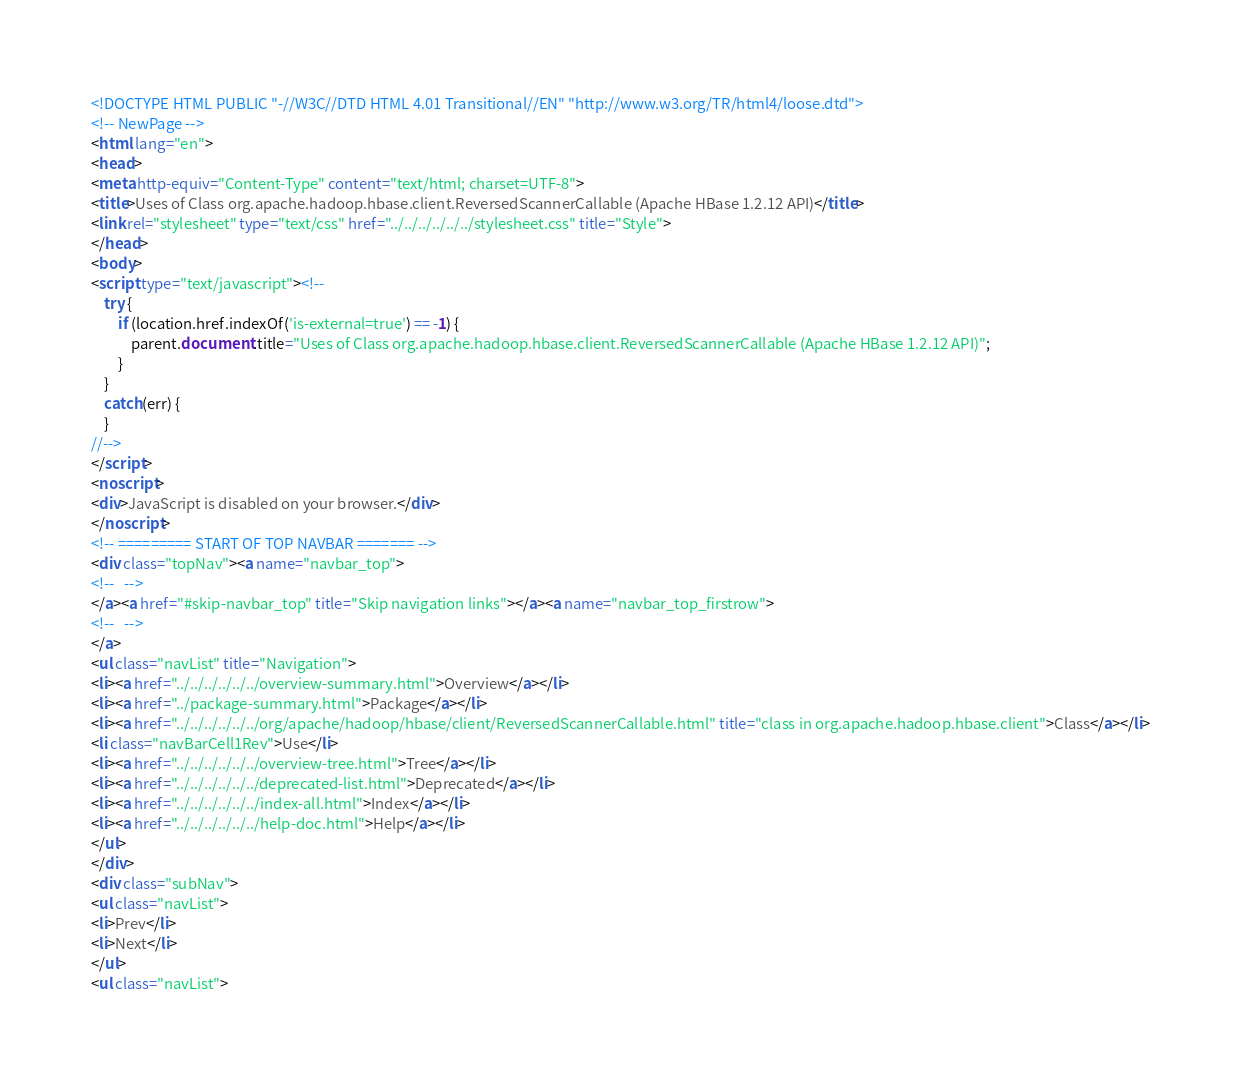<code> <loc_0><loc_0><loc_500><loc_500><_HTML_><!DOCTYPE HTML PUBLIC "-//W3C//DTD HTML 4.01 Transitional//EN" "http://www.w3.org/TR/html4/loose.dtd">
<!-- NewPage -->
<html lang="en">
<head>
<meta http-equiv="Content-Type" content="text/html; charset=UTF-8">
<title>Uses of Class org.apache.hadoop.hbase.client.ReversedScannerCallable (Apache HBase 1.2.12 API)</title>
<link rel="stylesheet" type="text/css" href="../../../../../../stylesheet.css" title="Style">
</head>
<body>
<script type="text/javascript"><!--
    try {
        if (location.href.indexOf('is-external=true') == -1) {
            parent.document.title="Uses of Class org.apache.hadoop.hbase.client.ReversedScannerCallable (Apache HBase 1.2.12 API)";
        }
    }
    catch(err) {
    }
//-->
</script>
<noscript>
<div>JavaScript is disabled on your browser.</div>
</noscript>
<!-- ========= START OF TOP NAVBAR ======= -->
<div class="topNav"><a name="navbar_top">
<!--   -->
</a><a href="#skip-navbar_top" title="Skip navigation links"></a><a name="navbar_top_firstrow">
<!--   -->
</a>
<ul class="navList" title="Navigation">
<li><a href="../../../../../../overview-summary.html">Overview</a></li>
<li><a href="../package-summary.html">Package</a></li>
<li><a href="../../../../../../org/apache/hadoop/hbase/client/ReversedScannerCallable.html" title="class in org.apache.hadoop.hbase.client">Class</a></li>
<li class="navBarCell1Rev">Use</li>
<li><a href="../../../../../../overview-tree.html">Tree</a></li>
<li><a href="../../../../../../deprecated-list.html">Deprecated</a></li>
<li><a href="../../../../../../index-all.html">Index</a></li>
<li><a href="../../../../../../help-doc.html">Help</a></li>
</ul>
</div>
<div class="subNav">
<ul class="navList">
<li>Prev</li>
<li>Next</li>
</ul>
<ul class="navList"></code> 